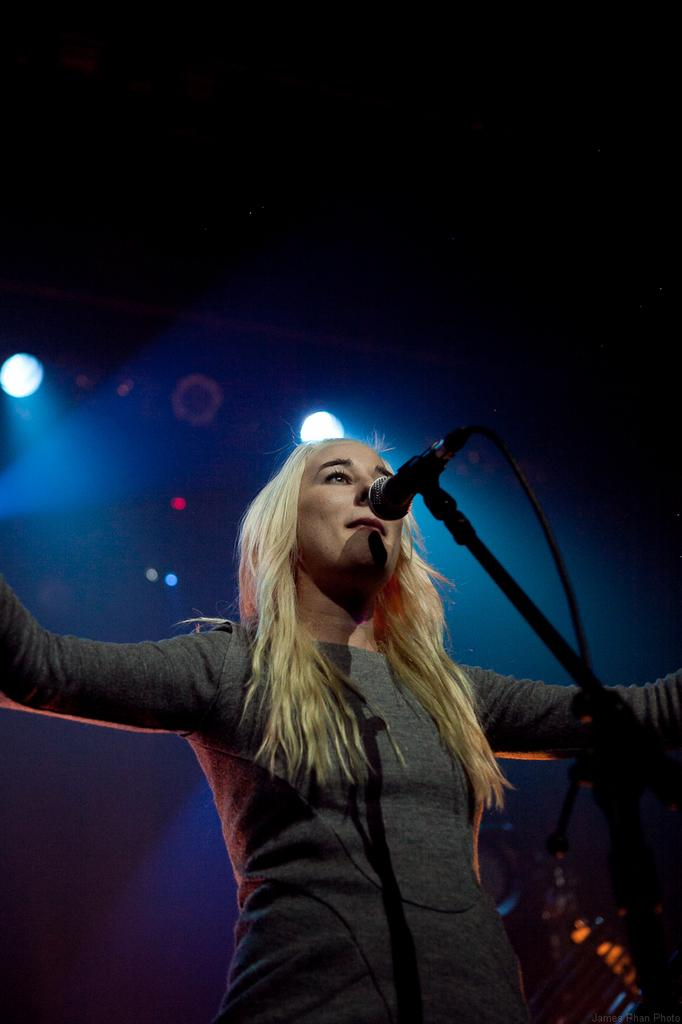Who is the main subject in the image? There is a woman in the image. What is the woman wearing? The woman is wearing a grey dress. What is the woman doing in the image? The woman is standing. What object is in front of the woman? There is a microphone in front of the woman. What can be seen in the background of the image? The background of the image is dark. What type of ornament is the woman holding in the image? There is no ornament present in the image. How does the woman express disgust in the image? The image does not show the woman expressing disgust; she is simply standing with a microphone in front of her. 